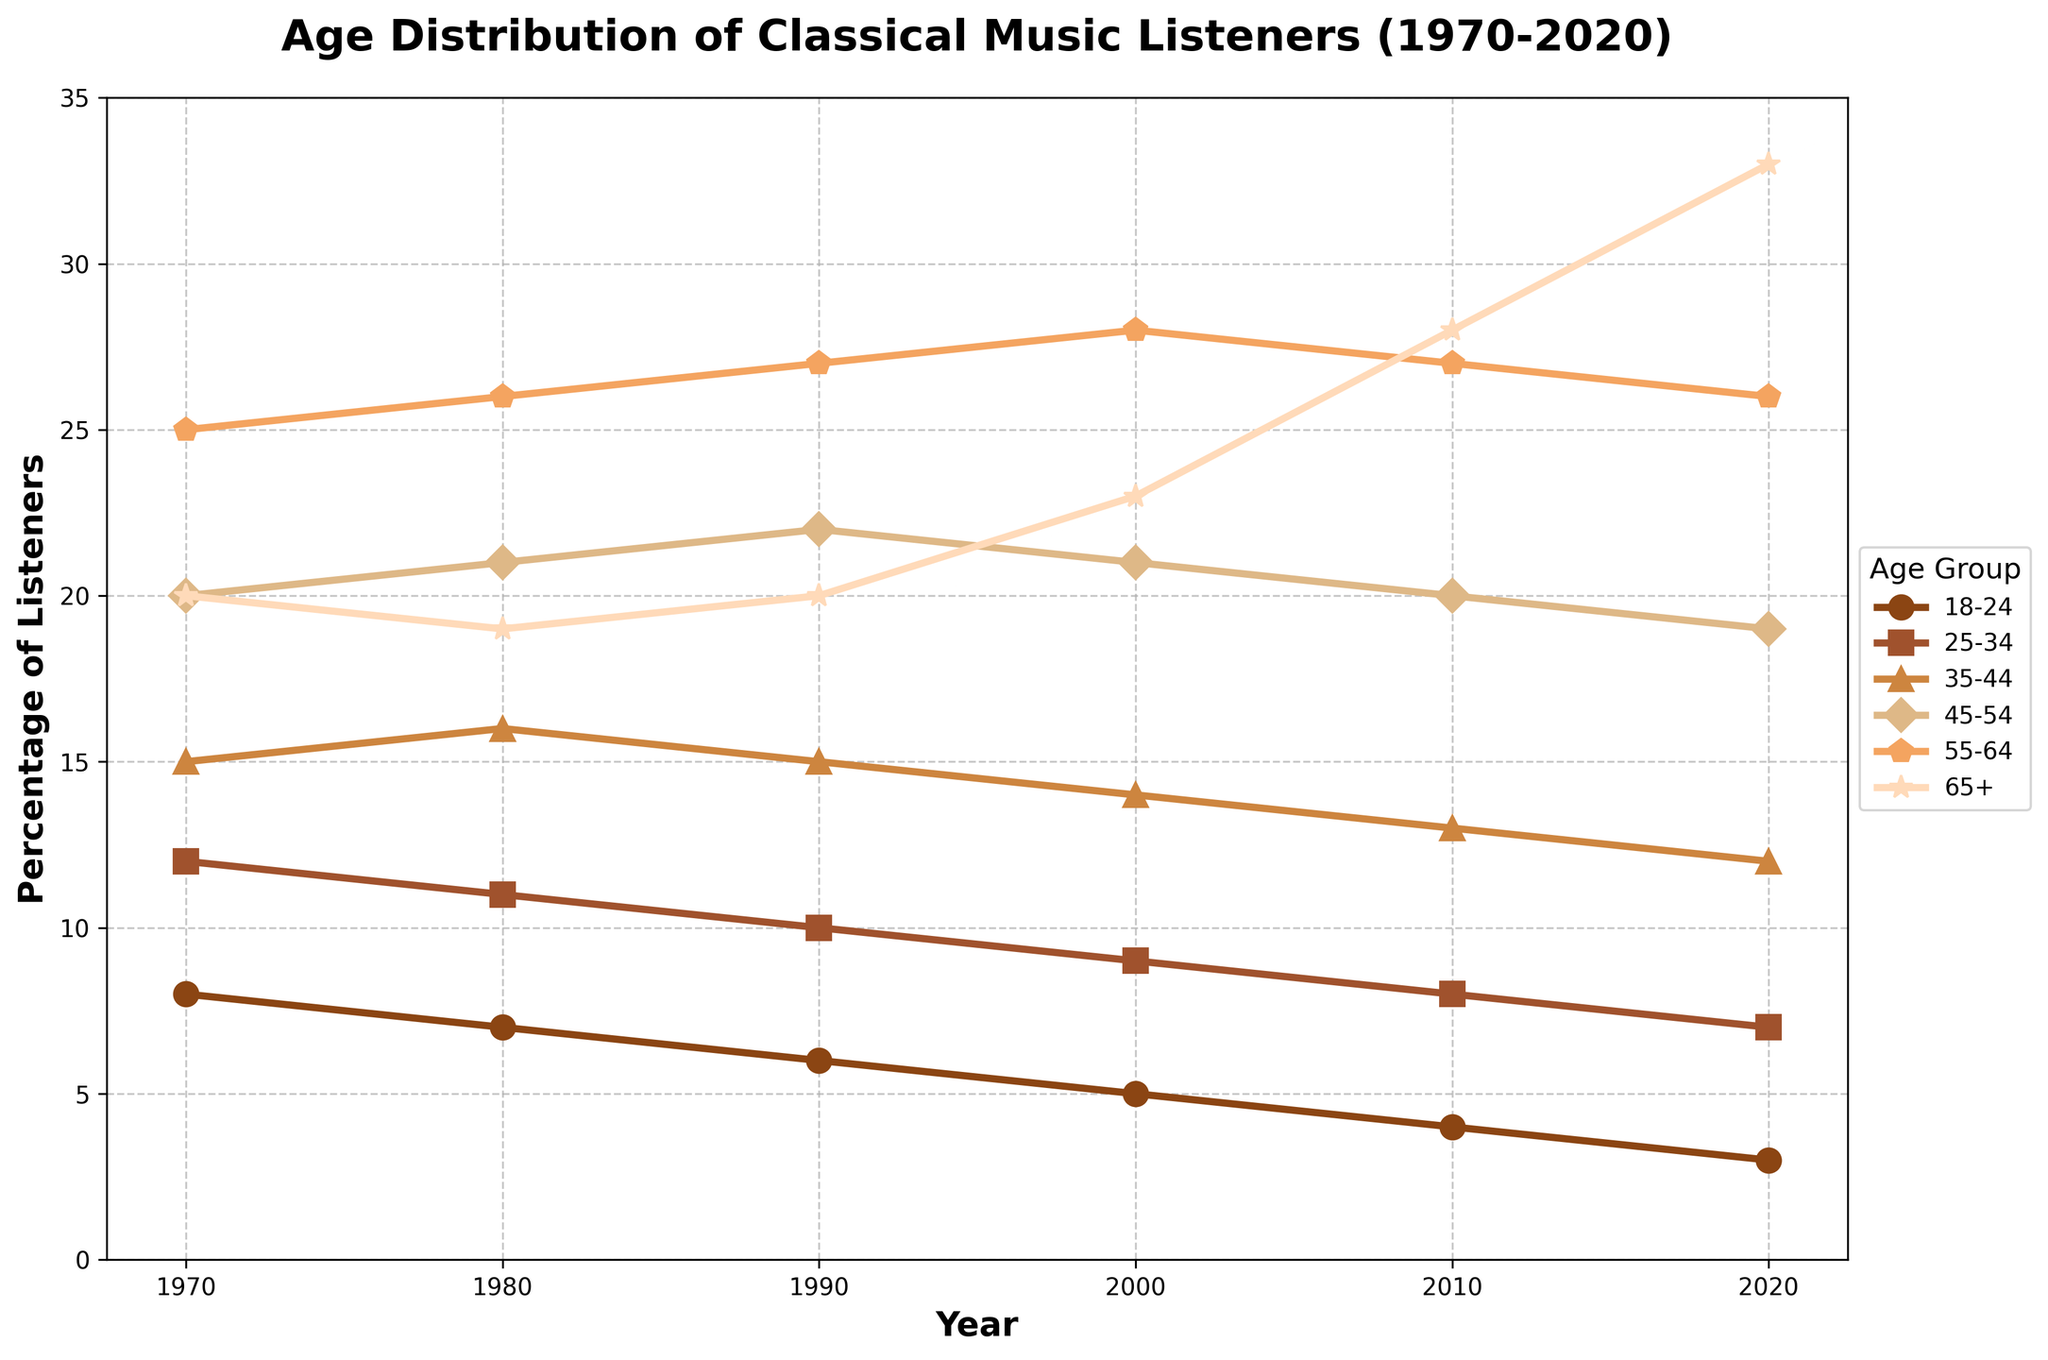What age group has seen the most growth in classical music listeners from 1970 to 2020? To find the age group with the most growth, we need to calculate the difference in percentage for each age group between 2020 and 1970. The 65+ age group grew from 20% to 33%, showing a growth of 13 percentage points. Other groups have either declined or shown lesser growth.
Answer: 65+ Which age group experienced a consistent decline in the percentage of listeners over the entire period from 1970 to 2020? Observing the trends, the age groups 18-24 and 25-34 consistently declined from 1970 to 2020. The 18-24 group decreased from 8% to 3%, and the 25-34 group decreased from 12% to 7%.
Answer: 18-24 and 25-34 What is the total percentage of classical music listeners aged 55-64 and 65+ in 2020? To find the total, add the percentages for the 55-64 and 65+ age groups in 2020. For 55-64, it is 26%, and for 65+, it is 33%. The sum is 26 + 33 = 59%.
Answer: 59% In which decade did the age group 35-44 experience the highest percentage of listeners? We analyze the data for each decade and observe that the highest percentage for the 35-44 age group was 16% in the 1980s.
Answer: 1980s Between 1990 and 2020, which age group showed the least change in the percentage of listeners? Calculating the percentage change for each group: 18-24 (6 to 3, change of -3), 25-34 (10 to 7, change of -3), 35-44 (15 to 12, change of -3), 45-54 (22 to 19, change of -3), 55-64 (27 to 26, change of -1), 65+ (20 to 33, change of +13). The 55-64 age group had the least change of -1 percentage point.
Answer: 55-64 What is the average percentage of listeners aged 45-54 over the displayed decades? To calculate the average, sum the percentages for the 45-54 age group across all decades and divide by the number of data points. Average = (20+21+22+21+20+19)/6 = 123/6 = 20.5%.
Answer: 20.5% How did the percentage of listeners aged 65+ change from 2000 to 2020? To find the change, subtract the percentage in 2000 from that in 2020 for the 65+ age group. Change = 33 - 23 = 10 percentage points.
Answer: +10 Which age group had the largest percentage of listeners in 2010? By looking at the percentages for 2010, the highest value is for the 65+ age group, which had 28%.
Answer: 65+ How does the percentage of listeners aged 18-24 in 2020 compare to that in 1970? The percentage of listeners aged 18-24 decreased from 8% in 1970 to 3% in 2020, showing a decrease of 5 percentage points.
Answer: Decreased by 5 Which age groups had approximately the same percentage of listeners in any given year, and in which year did this occur? We need to find age groups with similar percentages in any year. In 2000, the 18-24 and 25-34 age groups both had almost identical values: 5% and 9%, respectively. This is the closest pair of values among all age groups across different years.
Answer: 2000 